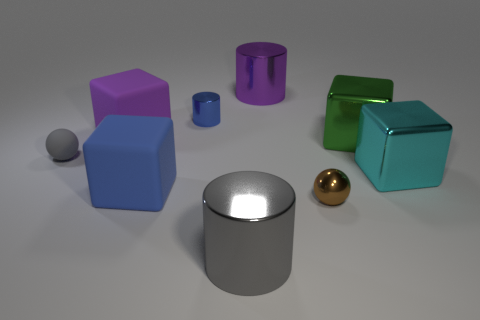Subtract all blue rubber cubes. How many cubes are left? 3 Subtract all green cubes. How many cubes are left? 3 Subtract all spheres. How many objects are left? 7 Subtract all small brown matte spheres. Subtract all large purple cylinders. How many objects are left? 8 Add 4 gray matte objects. How many gray matte objects are left? 5 Add 5 small matte blocks. How many small matte blocks exist? 5 Subtract 1 gray cylinders. How many objects are left? 8 Subtract all brown cubes. Subtract all blue spheres. How many cubes are left? 4 